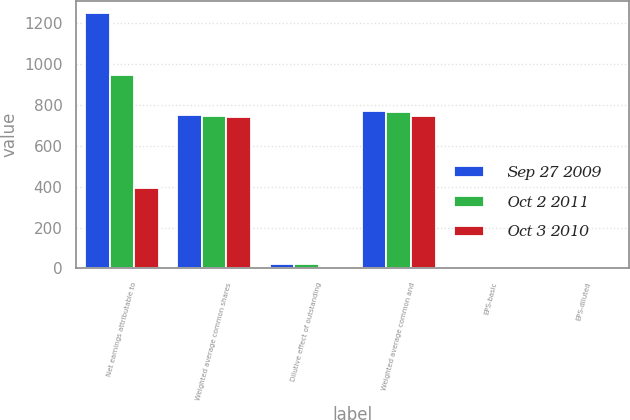Convert chart to OTSL. <chart><loc_0><loc_0><loc_500><loc_500><stacked_bar_chart><ecel><fcel>Net earnings attributable to<fcel>Weighted average common shares<fcel>Dilutive effect of outstanding<fcel>Weighted average common and<fcel>EPS-basic<fcel>EPS-diluted<nl><fcel>Sep 27 2009<fcel>1245.7<fcel>748.3<fcel>21.4<fcel>769.7<fcel>1.66<fcel>1.62<nl><fcel>Oct 2 2011<fcel>945.6<fcel>744.4<fcel>19.8<fcel>764.2<fcel>1.27<fcel>1.24<nl><fcel>Oct 3 2010<fcel>390.8<fcel>738.7<fcel>7.2<fcel>745.9<fcel>0.53<fcel>0.52<nl></chart> 